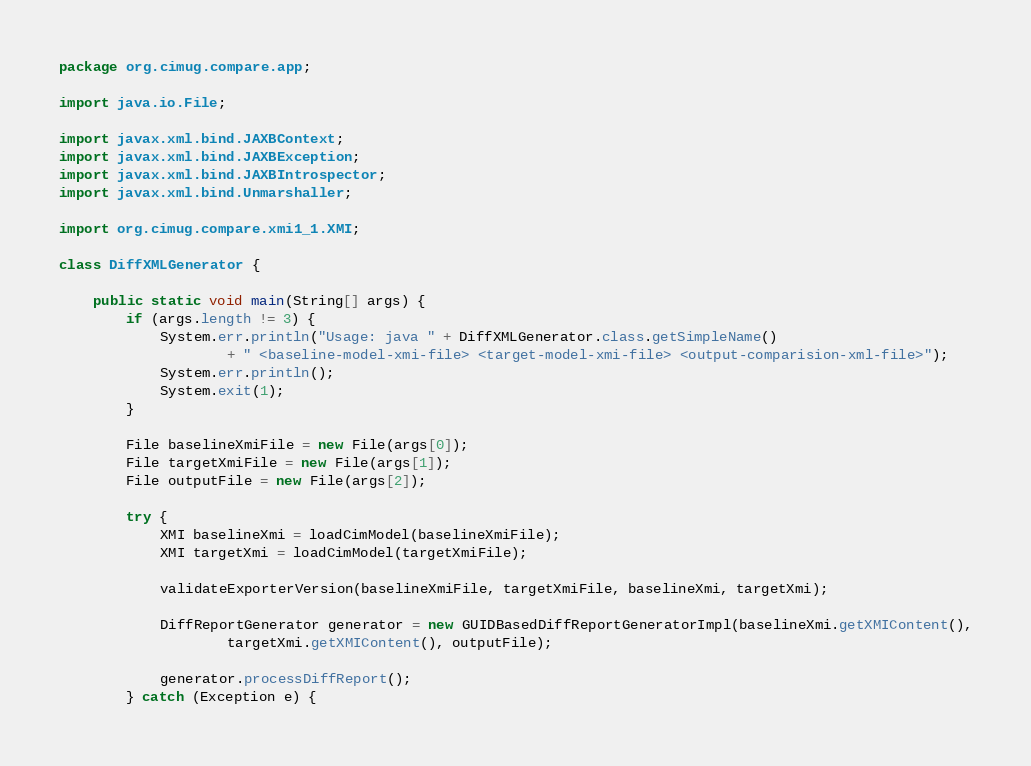<code> <loc_0><loc_0><loc_500><loc_500><_Java_>package org.cimug.compare.app;

import java.io.File;

import javax.xml.bind.JAXBContext;
import javax.xml.bind.JAXBException;
import javax.xml.bind.JAXBIntrospector;
import javax.xml.bind.Unmarshaller;

import org.cimug.compare.xmi1_1.XMI;

class DiffXMLGenerator {

	public static void main(String[] args) {
		if (args.length != 3) {
			System.err.println("Usage: java " + DiffXMLGenerator.class.getSimpleName()
					+ " <baseline-model-xmi-file> <target-model-xmi-file> <output-comparision-xml-file>");
			System.err.println();
			System.exit(1);
		}

		File baselineXmiFile = new File(args[0]);
		File targetXmiFile = new File(args[1]);
		File outputFile = new File(args[2]);

		try {
			XMI baselineXmi = loadCimModel(baselineXmiFile);
			XMI targetXmi = loadCimModel(targetXmiFile);

			validateExporterVersion(baselineXmiFile, targetXmiFile, baselineXmi, targetXmi);

			DiffReportGenerator generator = new GUIDBasedDiffReportGeneratorImpl(baselineXmi.getXMIContent(),
					targetXmi.getXMIContent(), outputFile);

			generator.processDiffReport();
		} catch (Exception e) {</code> 